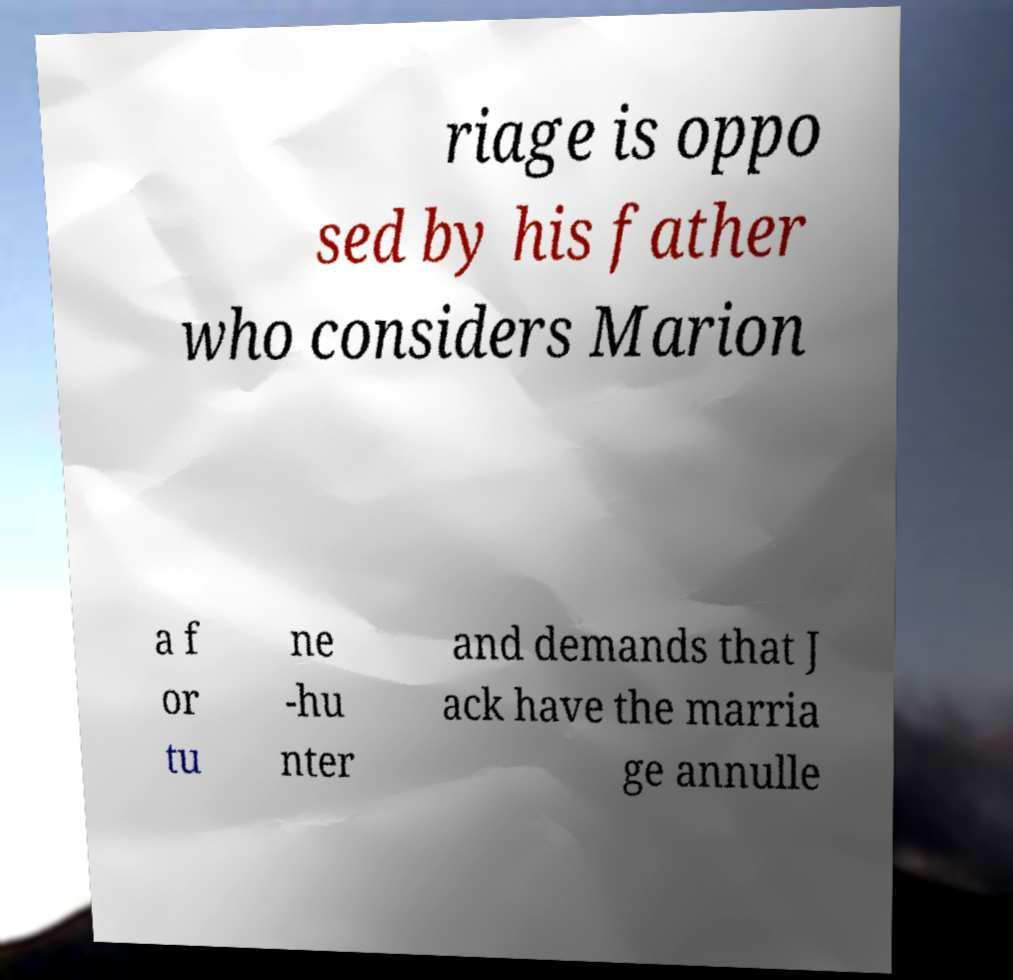Could you extract and type out the text from this image? riage is oppo sed by his father who considers Marion a f or tu ne -hu nter and demands that J ack have the marria ge annulle 